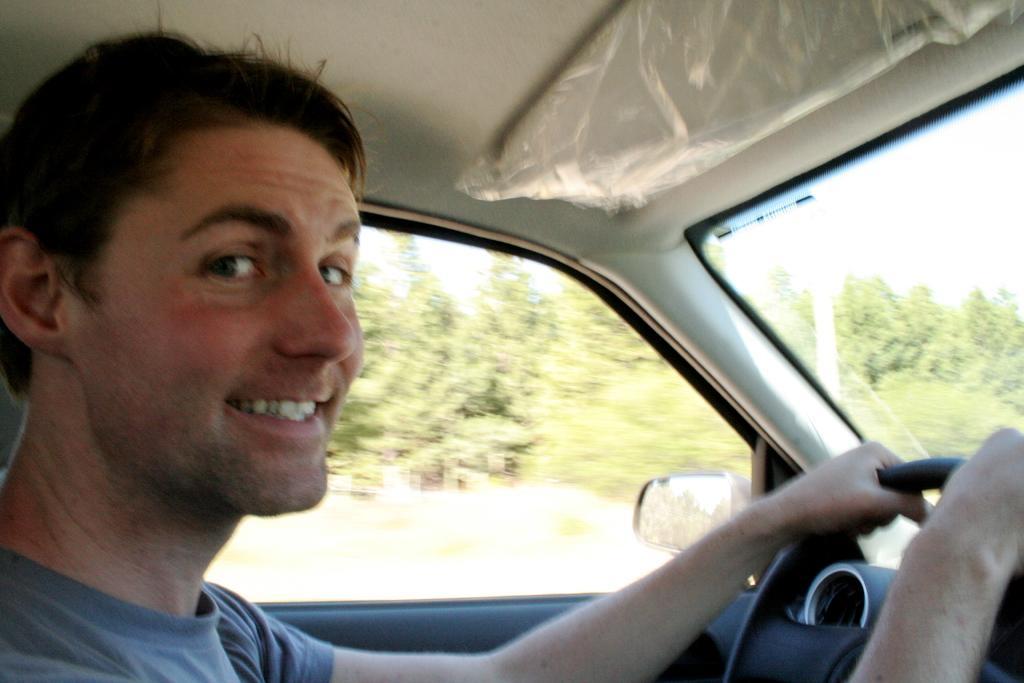Please provide a concise description of this image. In this picture we can see a man inside the vehicle. This is mirror and these are the trees. 